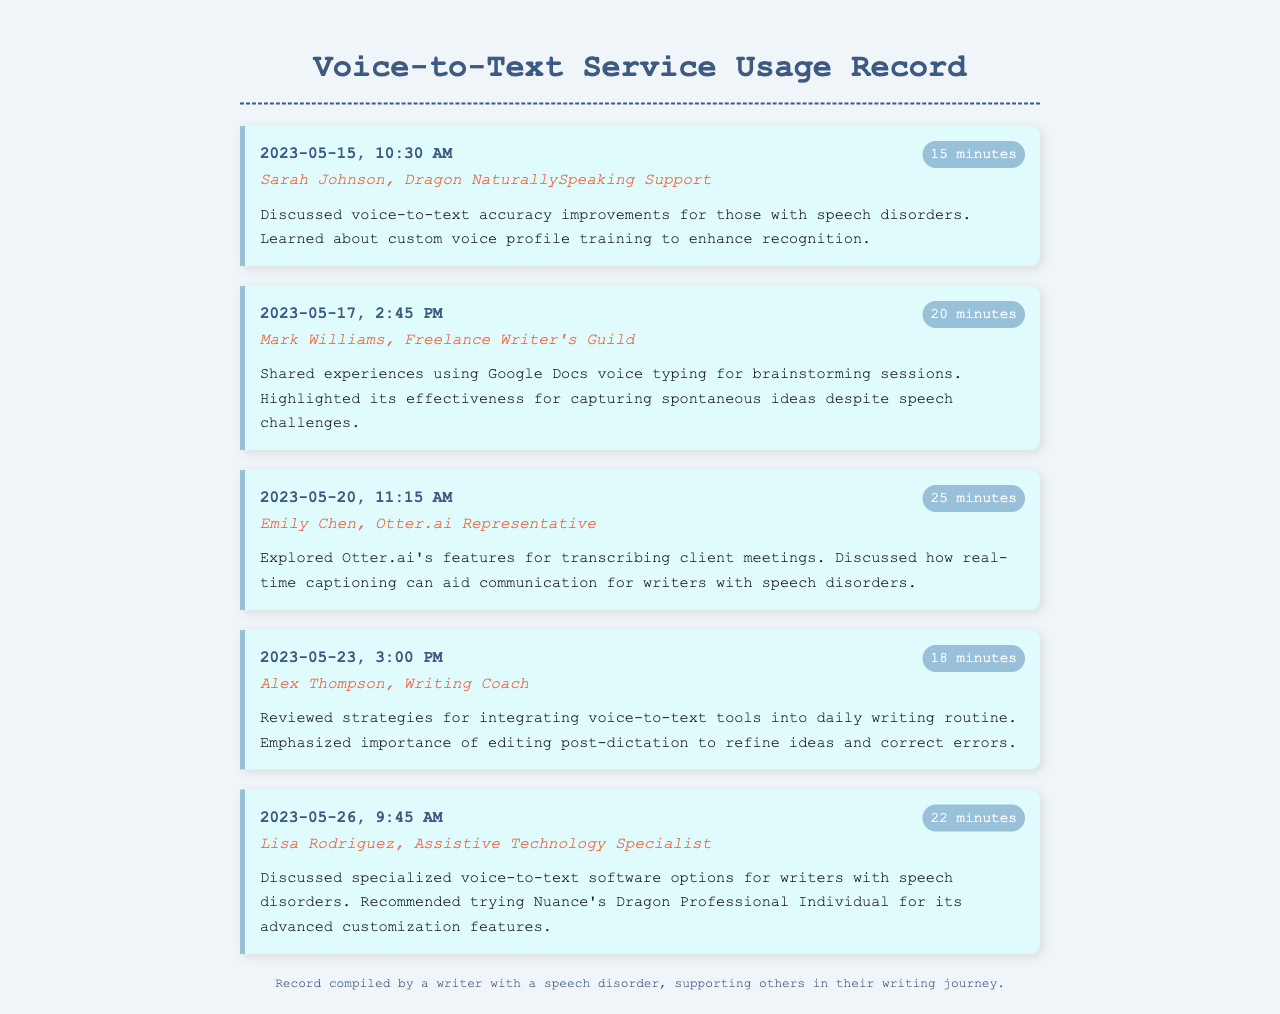What is the duration of the call with Sarah Johnson? The duration of the call with Sarah Johnson, as noted in the record, is 15 minutes.
Answer: 15 minutes What date was the call with Alex Thompson made? The date of the call with Alex Thompson is recorded as 2023-05-23.
Answer: 2023-05-23 Who did the writer discuss specialized voice-to-text software options with? The writer discussed specialized voice-to-text software options with Lisa Rodriguez.
Answer: Lisa Rodriguez How long was the call with Emily Chen? The call with Emily Chen lasted for 25 minutes, as stated in the record.
Answer: 25 minutes What key feature of Otter.ai was discussed in the call with Emily Chen? The key feature discussed was real-time captioning that aids communication for writers.
Answer: Real-time captioning What common theme is observed in all conversations documented? The common theme is the exploration of voice-to-text tools and their benefits for people with speech disorders.
Answer: Voice-to-text tools for speech disorders Which voice-to-text service was recommended by Lisa Rodriguez? Lisa Rodriguez recommended Nuance's Dragon Professional Individual for its advanced customization features.
Answer: Nuance's Dragon Professional Individual What time was the call with Mark Williams? The call with Mark Williams took place at 2:45 PM.
Answer: 2:45 PM What support does the footer provide? The footer indicates that the record was compiled by a writer with a speech disorder, supporting others in their writing journey.
Answer: Support for others in writing journey 